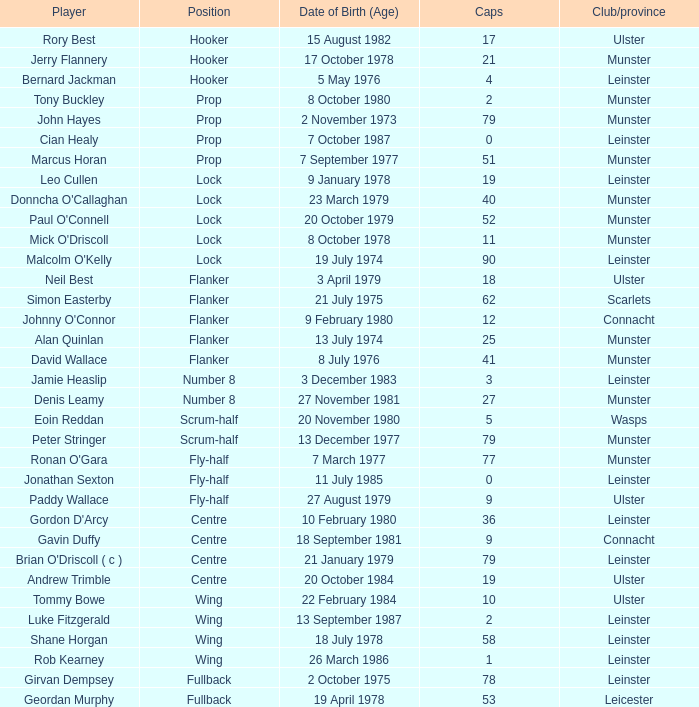Which club or province has jonathan sexton as a player and less than 2 caps? Leinster. 